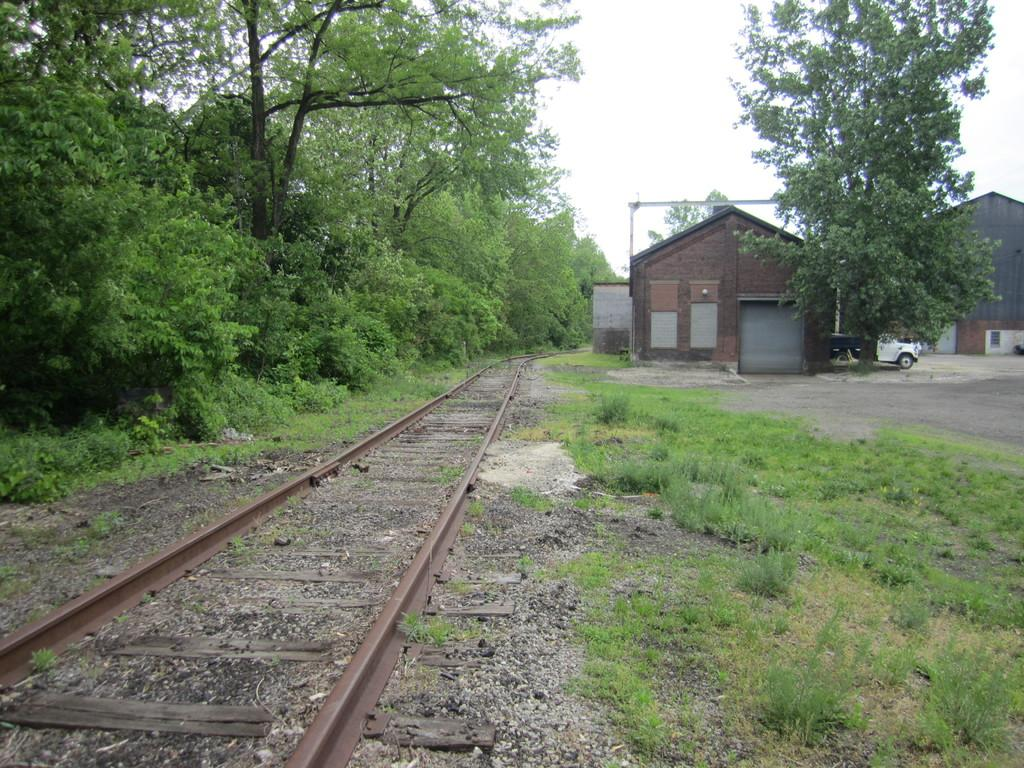What type of vegetation can be seen in the image? There are trees in the image. What type of structures are present in the image? There are houses in the image. What is the ground covered with in the image? There is grass in the image. What type of transportation infrastructure is visible in the image? There is a railway track in the image. What type of vehicle can be seen in the image? There is a white color car in the image. What is visible at the top of the image? The sky is visible at the top of the image. How does the cloth affect the profit in the image? There is no mention of cloth or profit in the image; it features trees, houses, grass, a railway track, a white color car, and the sky. What type of respect can be seen in the image? There is no indication of respect or any related actions in the image. 